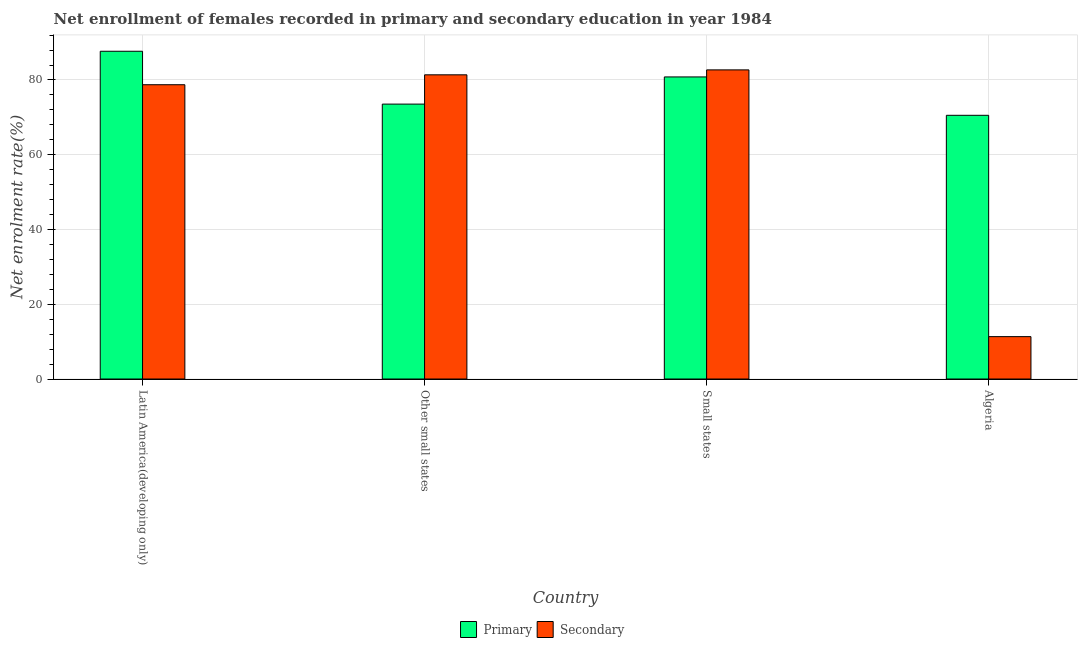How many groups of bars are there?
Make the answer very short. 4. Are the number of bars per tick equal to the number of legend labels?
Ensure brevity in your answer.  Yes. How many bars are there on the 4th tick from the right?
Make the answer very short. 2. What is the label of the 3rd group of bars from the left?
Make the answer very short. Small states. In how many cases, is the number of bars for a given country not equal to the number of legend labels?
Provide a succinct answer. 0. What is the enrollment rate in secondary education in Latin America(developing only)?
Offer a terse response. 78.72. Across all countries, what is the maximum enrollment rate in secondary education?
Your response must be concise. 82.69. Across all countries, what is the minimum enrollment rate in primary education?
Your answer should be compact. 70.54. In which country was the enrollment rate in secondary education maximum?
Offer a very short reply. Small states. In which country was the enrollment rate in secondary education minimum?
Provide a short and direct response. Algeria. What is the total enrollment rate in primary education in the graph?
Offer a very short reply. 312.57. What is the difference between the enrollment rate in secondary education in Algeria and that in Other small states?
Provide a short and direct response. -70.03. What is the difference between the enrollment rate in primary education in Latin America(developing only) and the enrollment rate in secondary education in Algeria?
Give a very brief answer. 76.34. What is the average enrollment rate in primary education per country?
Provide a short and direct response. 78.14. What is the difference between the enrollment rate in primary education and enrollment rate in secondary education in Small states?
Make the answer very short. -1.88. What is the ratio of the enrollment rate in primary education in Algeria to that in Latin America(developing only)?
Your response must be concise. 0.8. Is the difference between the enrollment rate in primary education in Algeria and Small states greater than the difference between the enrollment rate in secondary education in Algeria and Small states?
Give a very brief answer. Yes. What is the difference between the highest and the second highest enrollment rate in primary education?
Ensure brevity in your answer.  6.87. What is the difference between the highest and the lowest enrollment rate in primary education?
Your answer should be compact. 17.13. In how many countries, is the enrollment rate in secondary education greater than the average enrollment rate in secondary education taken over all countries?
Provide a succinct answer. 3. What does the 2nd bar from the left in Small states represents?
Give a very brief answer. Secondary. What does the 1st bar from the right in Other small states represents?
Provide a succinct answer. Secondary. Are all the bars in the graph horizontal?
Your answer should be very brief. No. What is the difference between two consecutive major ticks on the Y-axis?
Provide a short and direct response. 20. Are the values on the major ticks of Y-axis written in scientific E-notation?
Your answer should be compact. No. Does the graph contain any zero values?
Ensure brevity in your answer.  No. Where does the legend appear in the graph?
Keep it short and to the point. Bottom center. How many legend labels are there?
Your response must be concise. 2. How are the legend labels stacked?
Provide a short and direct response. Horizontal. What is the title of the graph?
Make the answer very short. Net enrollment of females recorded in primary and secondary education in year 1984. Does "Health Care" appear as one of the legend labels in the graph?
Your response must be concise. No. What is the label or title of the Y-axis?
Your answer should be very brief. Net enrolment rate(%). What is the Net enrolment rate(%) of Primary in Latin America(developing only)?
Ensure brevity in your answer.  87.67. What is the Net enrolment rate(%) of Secondary in Latin America(developing only)?
Your response must be concise. 78.72. What is the Net enrolment rate(%) in Primary in Other small states?
Offer a very short reply. 73.54. What is the Net enrolment rate(%) in Secondary in Other small states?
Make the answer very short. 81.37. What is the Net enrolment rate(%) of Primary in Small states?
Provide a succinct answer. 80.81. What is the Net enrolment rate(%) in Secondary in Small states?
Provide a short and direct response. 82.69. What is the Net enrolment rate(%) of Primary in Algeria?
Ensure brevity in your answer.  70.54. What is the Net enrolment rate(%) in Secondary in Algeria?
Your answer should be compact. 11.34. Across all countries, what is the maximum Net enrolment rate(%) of Primary?
Give a very brief answer. 87.67. Across all countries, what is the maximum Net enrolment rate(%) in Secondary?
Make the answer very short. 82.69. Across all countries, what is the minimum Net enrolment rate(%) of Primary?
Ensure brevity in your answer.  70.54. Across all countries, what is the minimum Net enrolment rate(%) of Secondary?
Your response must be concise. 11.34. What is the total Net enrolment rate(%) of Primary in the graph?
Provide a short and direct response. 312.57. What is the total Net enrolment rate(%) in Secondary in the graph?
Provide a succinct answer. 254.13. What is the difference between the Net enrolment rate(%) of Primary in Latin America(developing only) and that in Other small states?
Provide a short and direct response. 14.14. What is the difference between the Net enrolment rate(%) of Secondary in Latin America(developing only) and that in Other small states?
Keep it short and to the point. -2.65. What is the difference between the Net enrolment rate(%) of Primary in Latin America(developing only) and that in Small states?
Offer a terse response. 6.87. What is the difference between the Net enrolment rate(%) of Secondary in Latin America(developing only) and that in Small states?
Your answer should be compact. -3.97. What is the difference between the Net enrolment rate(%) in Primary in Latin America(developing only) and that in Algeria?
Provide a short and direct response. 17.13. What is the difference between the Net enrolment rate(%) of Secondary in Latin America(developing only) and that in Algeria?
Offer a very short reply. 67.39. What is the difference between the Net enrolment rate(%) of Primary in Other small states and that in Small states?
Your answer should be compact. -7.27. What is the difference between the Net enrolment rate(%) in Secondary in Other small states and that in Small states?
Your answer should be compact. -1.32. What is the difference between the Net enrolment rate(%) in Primary in Other small states and that in Algeria?
Your answer should be compact. 3. What is the difference between the Net enrolment rate(%) of Secondary in Other small states and that in Algeria?
Offer a very short reply. 70.03. What is the difference between the Net enrolment rate(%) of Primary in Small states and that in Algeria?
Ensure brevity in your answer.  10.27. What is the difference between the Net enrolment rate(%) of Secondary in Small states and that in Algeria?
Provide a succinct answer. 71.36. What is the difference between the Net enrolment rate(%) in Primary in Latin America(developing only) and the Net enrolment rate(%) in Secondary in Other small states?
Provide a short and direct response. 6.3. What is the difference between the Net enrolment rate(%) in Primary in Latin America(developing only) and the Net enrolment rate(%) in Secondary in Small states?
Keep it short and to the point. 4.98. What is the difference between the Net enrolment rate(%) in Primary in Latin America(developing only) and the Net enrolment rate(%) in Secondary in Algeria?
Your response must be concise. 76.34. What is the difference between the Net enrolment rate(%) in Primary in Other small states and the Net enrolment rate(%) in Secondary in Small states?
Your answer should be compact. -9.16. What is the difference between the Net enrolment rate(%) in Primary in Other small states and the Net enrolment rate(%) in Secondary in Algeria?
Make the answer very short. 62.2. What is the difference between the Net enrolment rate(%) of Primary in Small states and the Net enrolment rate(%) of Secondary in Algeria?
Your response must be concise. 69.47. What is the average Net enrolment rate(%) of Primary per country?
Your response must be concise. 78.14. What is the average Net enrolment rate(%) of Secondary per country?
Ensure brevity in your answer.  63.53. What is the difference between the Net enrolment rate(%) of Primary and Net enrolment rate(%) of Secondary in Latin America(developing only)?
Provide a succinct answer. 8.95. What is the difference between the Net enrolment rate(%) of Primary and Net enrolment rate(%) of Secondary in Other small states?
Offer a very short reply. -7.83. What is the difference between the Net enrolment rate(%) in Primary and Net enrolment rate(%) in Secondary in Small states?
Provide a short and direct response. -1.88. What is the difference between the Net enrolment rate(%) in Primary and Net enrolment rate(%) in Secondary in Algeria?
Keep it short and to the point. 59.2. What is the ratio of the Net enrolment rate(%) in Primary in Latin America(developing only) to that in Other small states?
Ensure brevity in your answer.  1.19. What is the ratio of the Net enrolment rate(%) of Secondary in Latin America(developing only) to that in Other small states?
Provide a short and direct response. 0.97. What is the ratio of the Net enrolment rate(%) of Primary in Latin America(developing only) to that in Small states?
Your response must be concise. 1.08. What is the ratio of the Net enrolment rate(%) in Primary in Latin America(developing only) to that in Algeria?
Your answer should be very brief. 1.24. What is the ratio of the Net enrolment rate(%) of Secondary in Latin America(developing only) to that in Algeria?
Keep it short and to the point. 6.94. What is the ratio of the Net enrolment rate(%) in Primary in Other small states to that in Small states?
Ensure brevity in your answer.  0.91. What is the ratio of the Net enrolment rate(%) in Secondary in Other small states to that in Small states?
Ensure brevity in your answer.  0.98. What is the ratio of the Net enrolment rate(%) in Primary in Other small states to that in Algeria?
Offer a very short reply. 1.04. What is the ratio of the Net enrolment rate(%) in Secondary in Other small states to that in Algeria?
Give a very brief answer. 7.18. What is the ratio of the Net enrolment rate(%) in Primary in Small states to that in Algeria?
Provide a short and direct response. 1.15. What is the ratio of the Net enrolment rate(%) of Secondary in Small states to that in Algeria?
Your answer should be very brief. 7.29. What is the difference between the highest and the second highest Net enrolment rate(%) in Primary?
Give a very brief answer. 6.87. What is the difference between the highest and the second highest Net enrolment rate(%) of Secondary?
Make the answer very short. 1.32. What is the difference between the highest and the lowest Net enrolment rate(%) in Primary?
Make the answer very short. 17.13. What is the difference between the highest and the lowest Net enrolment rate(%) in Secondary?
Your response must be concise. 71.36. 